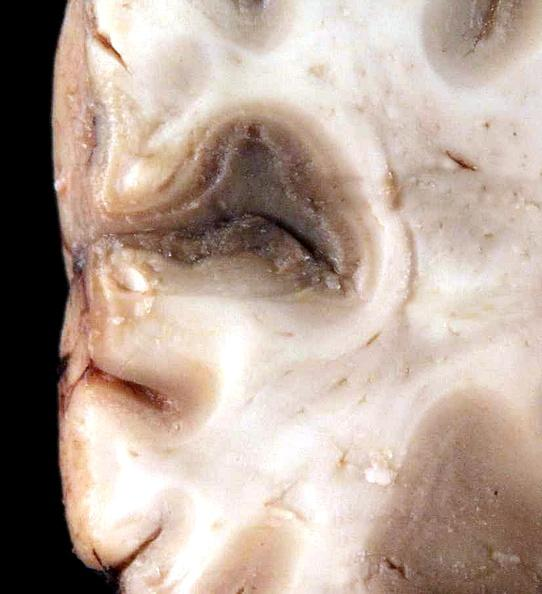s view of head with scalp present?
Answer the question using a single word or phrase. No 